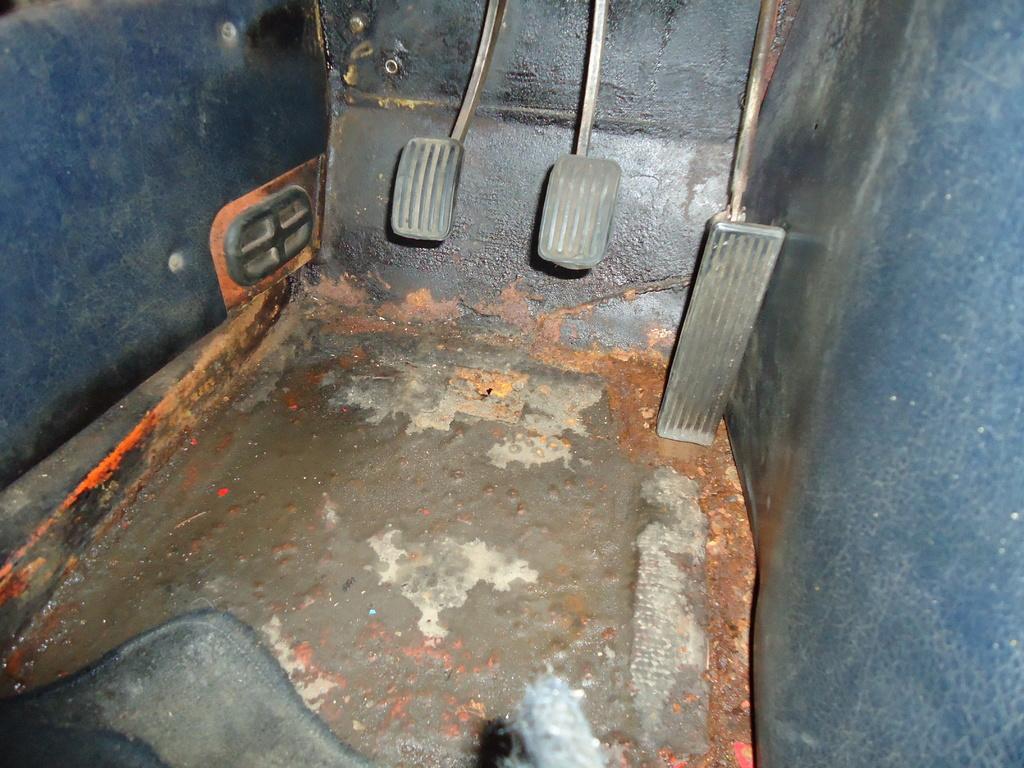Describe this image in one or two sentences. This picture describes about inside view of a vehicle, in this we can find few pedals. 